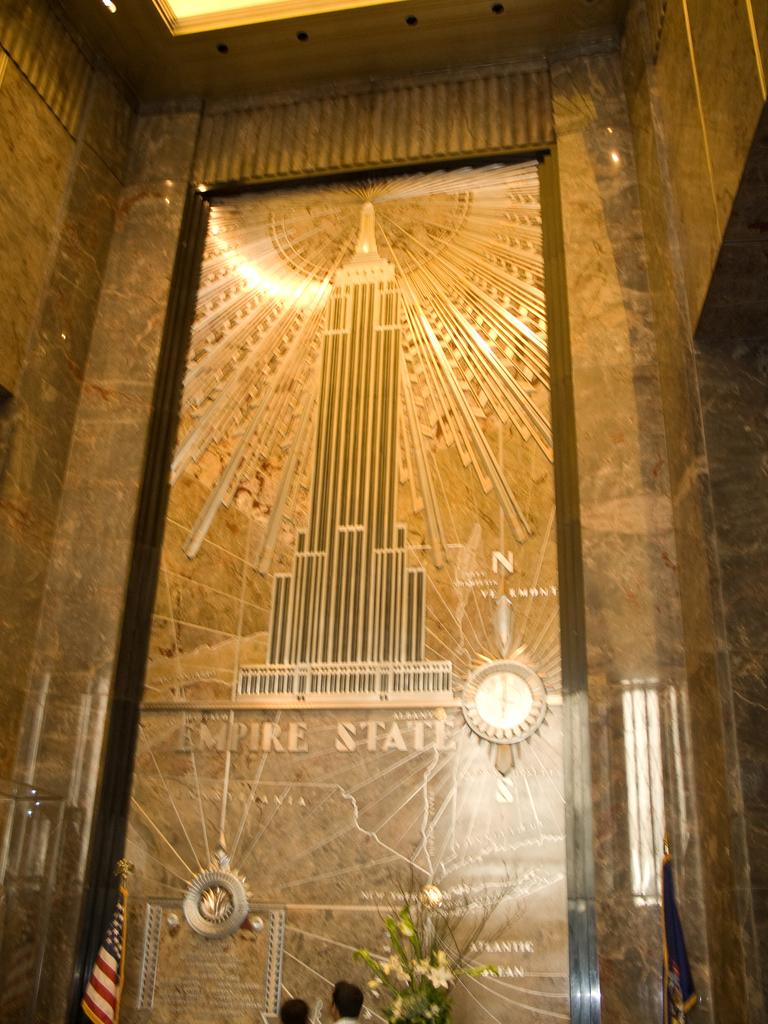What is present on the wall in the image? There is a sculpture of a building on the wall in the image. What time-telling device can be seen in the image? There is a clock in the image. What is located at the bottom of the image? There are flags and a flower vase at the bottom of the image. Are there any living beings in the image? Yes, there are people in the image. Is there any blood visible on the sculpture of the building in the image? No, there is no blood visible on the sculpture of the building in the image. Can you see a girl holding a popcorn bag in the image? There is no girl holding a popcorn bag in the image. 